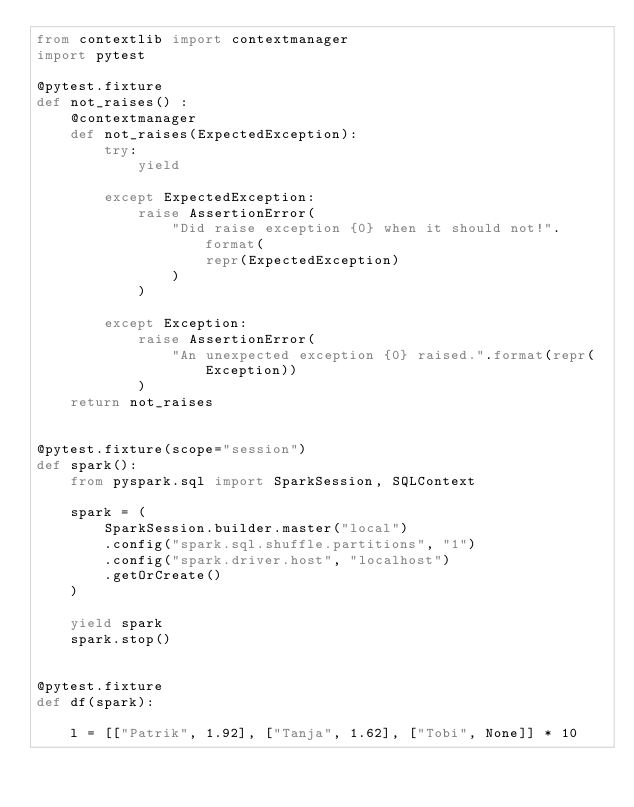<code> <loc_0><loc_0><loc_500><loc_500><_Python_>from contextlib import contextmanager
import pytest

@pytest.fixture
def not_raises() :
    @contextmanager
    def not_raises(ExpectedException):
        try:
            yield

        except ExpectedException:
            raise AssertionError(
                "Did raise exception {0} when it should not!".format(
                    repr(ExpectedException)
                )
            )

        except Exception:
            raise AssertionError(
                "An unexpected exception {0} raised.".format(repr(Exception))
            )
    return not_raises


@pytest.fixture(scope="session")
def spark():
    from pyspark.sql import SparkSession, SQLContext

    spark = (
        SparkSession.builder.master("local")
        .config("spark.sql.shuffle.partitions", "1")
        .config("spark.driver.host", "localhost")
        .getOrCreate()
    )

    yield spark
    spark.stop()


@pytest.fixture
def df(spark):

    l = [["Patrik", 1.92], ["Tanja", 1.62], ["Tobi", None]] * 10</code> 